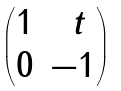<formula> <loc_0><loc_0><loc_500><loc_500>\begin{pmatrix} 1 & \ t \\ 0 & - 1 \end{pmatrix}</formula> 